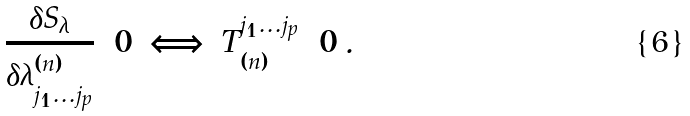<formula> <loc_0><loc_0><loc_500><loc_500>\frac { \delta S _ { \lambda } } { \delta \lambda ^ { ( n ) } _ { j _ { 1 } \dots j _ { p } } } = 0 \, \Longleftrightarrow \, T ^ { j _ { 1 } \dots j _ { p } } _ { ( n ) } = 0 \, .</formula> 